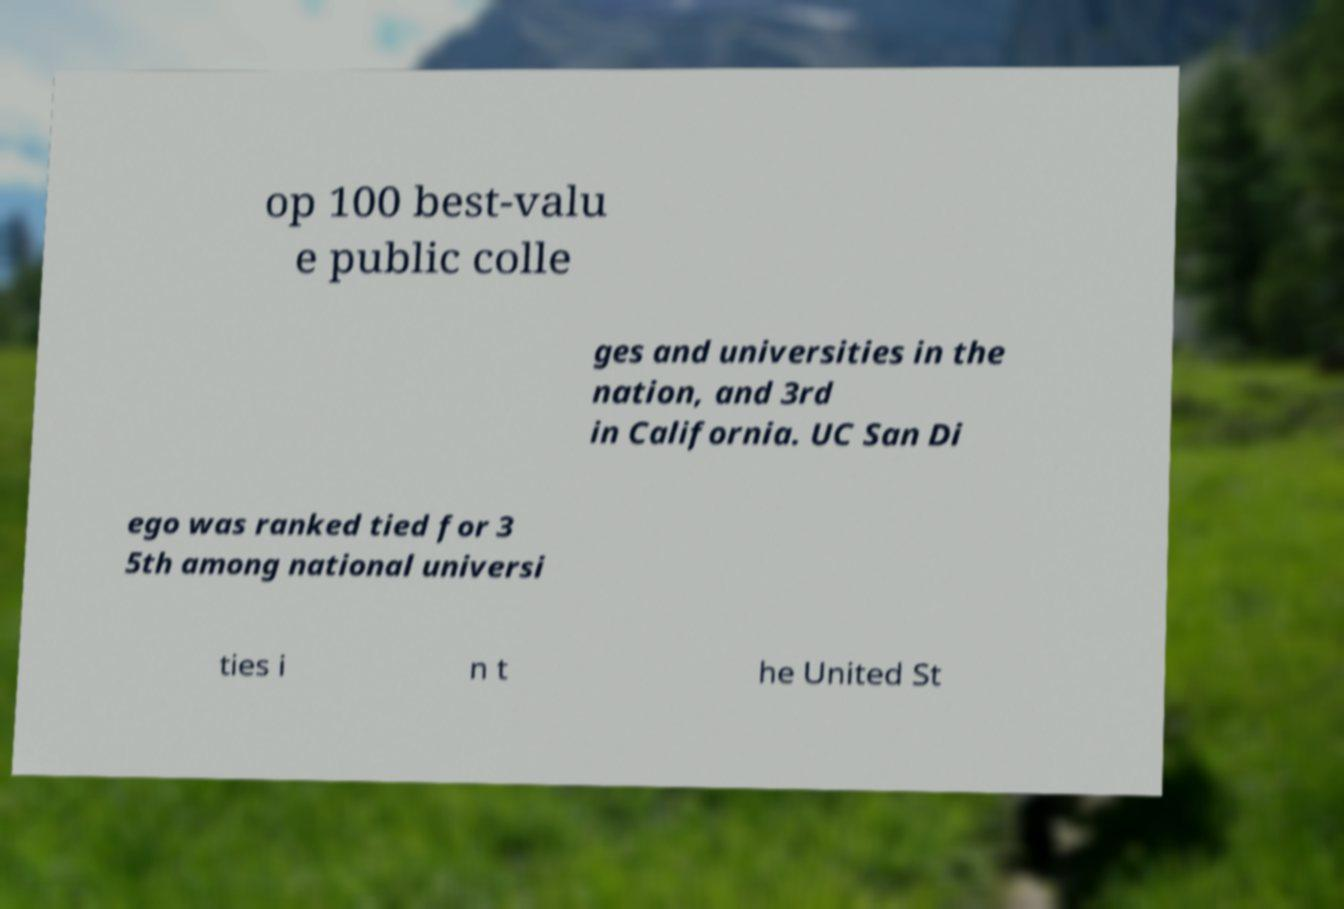Please identify and transcribe the text found in this image. op 100 best-valu e public colle ges and universities in the nation, and 3rd in California. UC San Di ego was ranked tied for 3 5th among national universi ties i n t he United St 